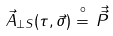<formula> <loc_0><loc_0><loc_500><loc_500>\vec { A } _ { \perp S } ( \tau , \vec { \sigma } ) \stackrel { \circ } { = } \, { \vec { \vec { P } } }</formula> 